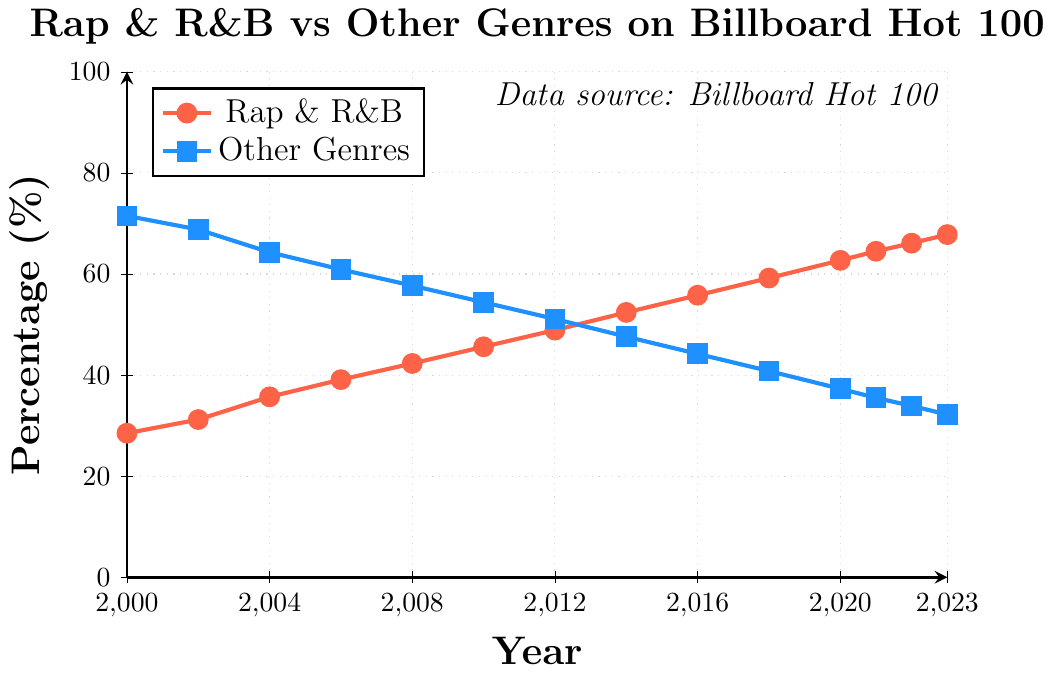What percentage of songs were Rap & R&B in 2012? Look at the plot for the year 2012 and identify the value on the Rap & R&B line.
Answer: 48.9% In which year did Rap & R&B songs surpass 50% on the Billboard Hot 100? Find the year where the Rap & R&B line crosses the 50% mark.
Answer: 2014 What is the difference in percentage of Rap & R&B songs between 2004 and 2014? Subtract the percentage of Rap & R&B in 2004 from the percentage in 2014. 52.4 - 35.7 = 16.7
Answer: 16.7 How much did the percentage of Other Genres decrease from 2000 to 2010? Subtract the percentage of Other Genres in 2010 from the percentage in 2000. 71.5 - 54.4 = 17.1
Answer: 17.1 Compare the percentages of Rap & R&B songs and Other Genres in 2023. Which is higher and by how much? Subtract the percentage of Other Genres in 2023 from the Rap & R&B percentage in 2023. 67.8 - 32.2 = 35.6
Answer: Rap & R&B by 35.6 What observation can you make about the trend of Rap & R&B songs from 2000 to 2023? The percentage of Rap & R&B songs on the Billboard Hot 100 generally increases each year from 28.5% in 2000 to 67.8% in 2023.
Answer: Increasing trend Identify two consecutive years where the increase in Rap & R&B songs was the greatest. Calculate the year-to-year differences and identify the consecutive years with the highest increase. (2020, 2021) had the highest increase: 64.5 - 62.7 = 1.8%
Answer: 2020 to 2021 How did the percentage of Other Genres change between 2008 and 2016? Calculate the percentage decrease. Subtract the percentage of Other Genres in 2016 from the percentage in 2008. 57.7 - 44.2 = 13.5
Answer: 13.5 What is the average percentage of Rap & R&B songs for the years 2014, 2016, and 2018? Calculate the average of the percentages for these years: (52.4 + 55.8 + 59.2) / 3.
Answer: 55.8 Which genre had a greater slope change from 2000 to 2023 in their respective lines, and what does it imply? Compare the slopes of the Rap & R&B line and Other Genres line over the years by evaluating their overall trend.
Answer: Rap & R&B, indicating a stronger increase 